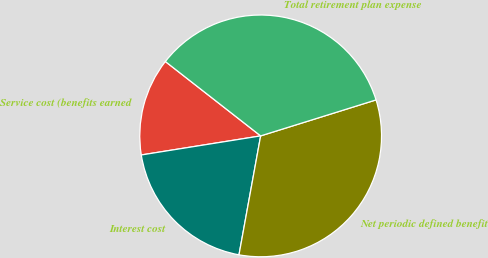Convert chart to OTSL. <chart><loc_0><loc_0><loc_500><loc_500><pie_chart><fcel>Service cost (benefits earned<fcel>Interest cost<fcel>Net periodic defined benefit<fcel>Total retirement plan expense<nl><fcel>13.07%<fcel>19.61%<fcel>32.68%<fcel>34.64%<nl></chart> 